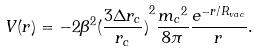Convert formula to latex. <formula><loc_0><loc_0><loc_500><loc_500>V ( r ) = - 2 \beta ^ { 2 } { ( \frac { 3 \Delta r _ { c } } { r _ { c } } ) } ^ { 2 } \frac { { m _ { c } } ^ { 2 } } { 8 \pi } \frac { e ^ { - r / R _ { v a c } } } { r } .</formula> 